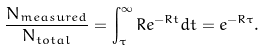Convert formula to latex. <formula><loc_0><loc_0><loc_500><loc_500>\frac { N _ { m e a s u r e d } } { N _ { t o t a l } } = \int _ { \tau } ^ { \infty } R e ^ { - R t } d t = e ^ { - R \tau } .</formula> 